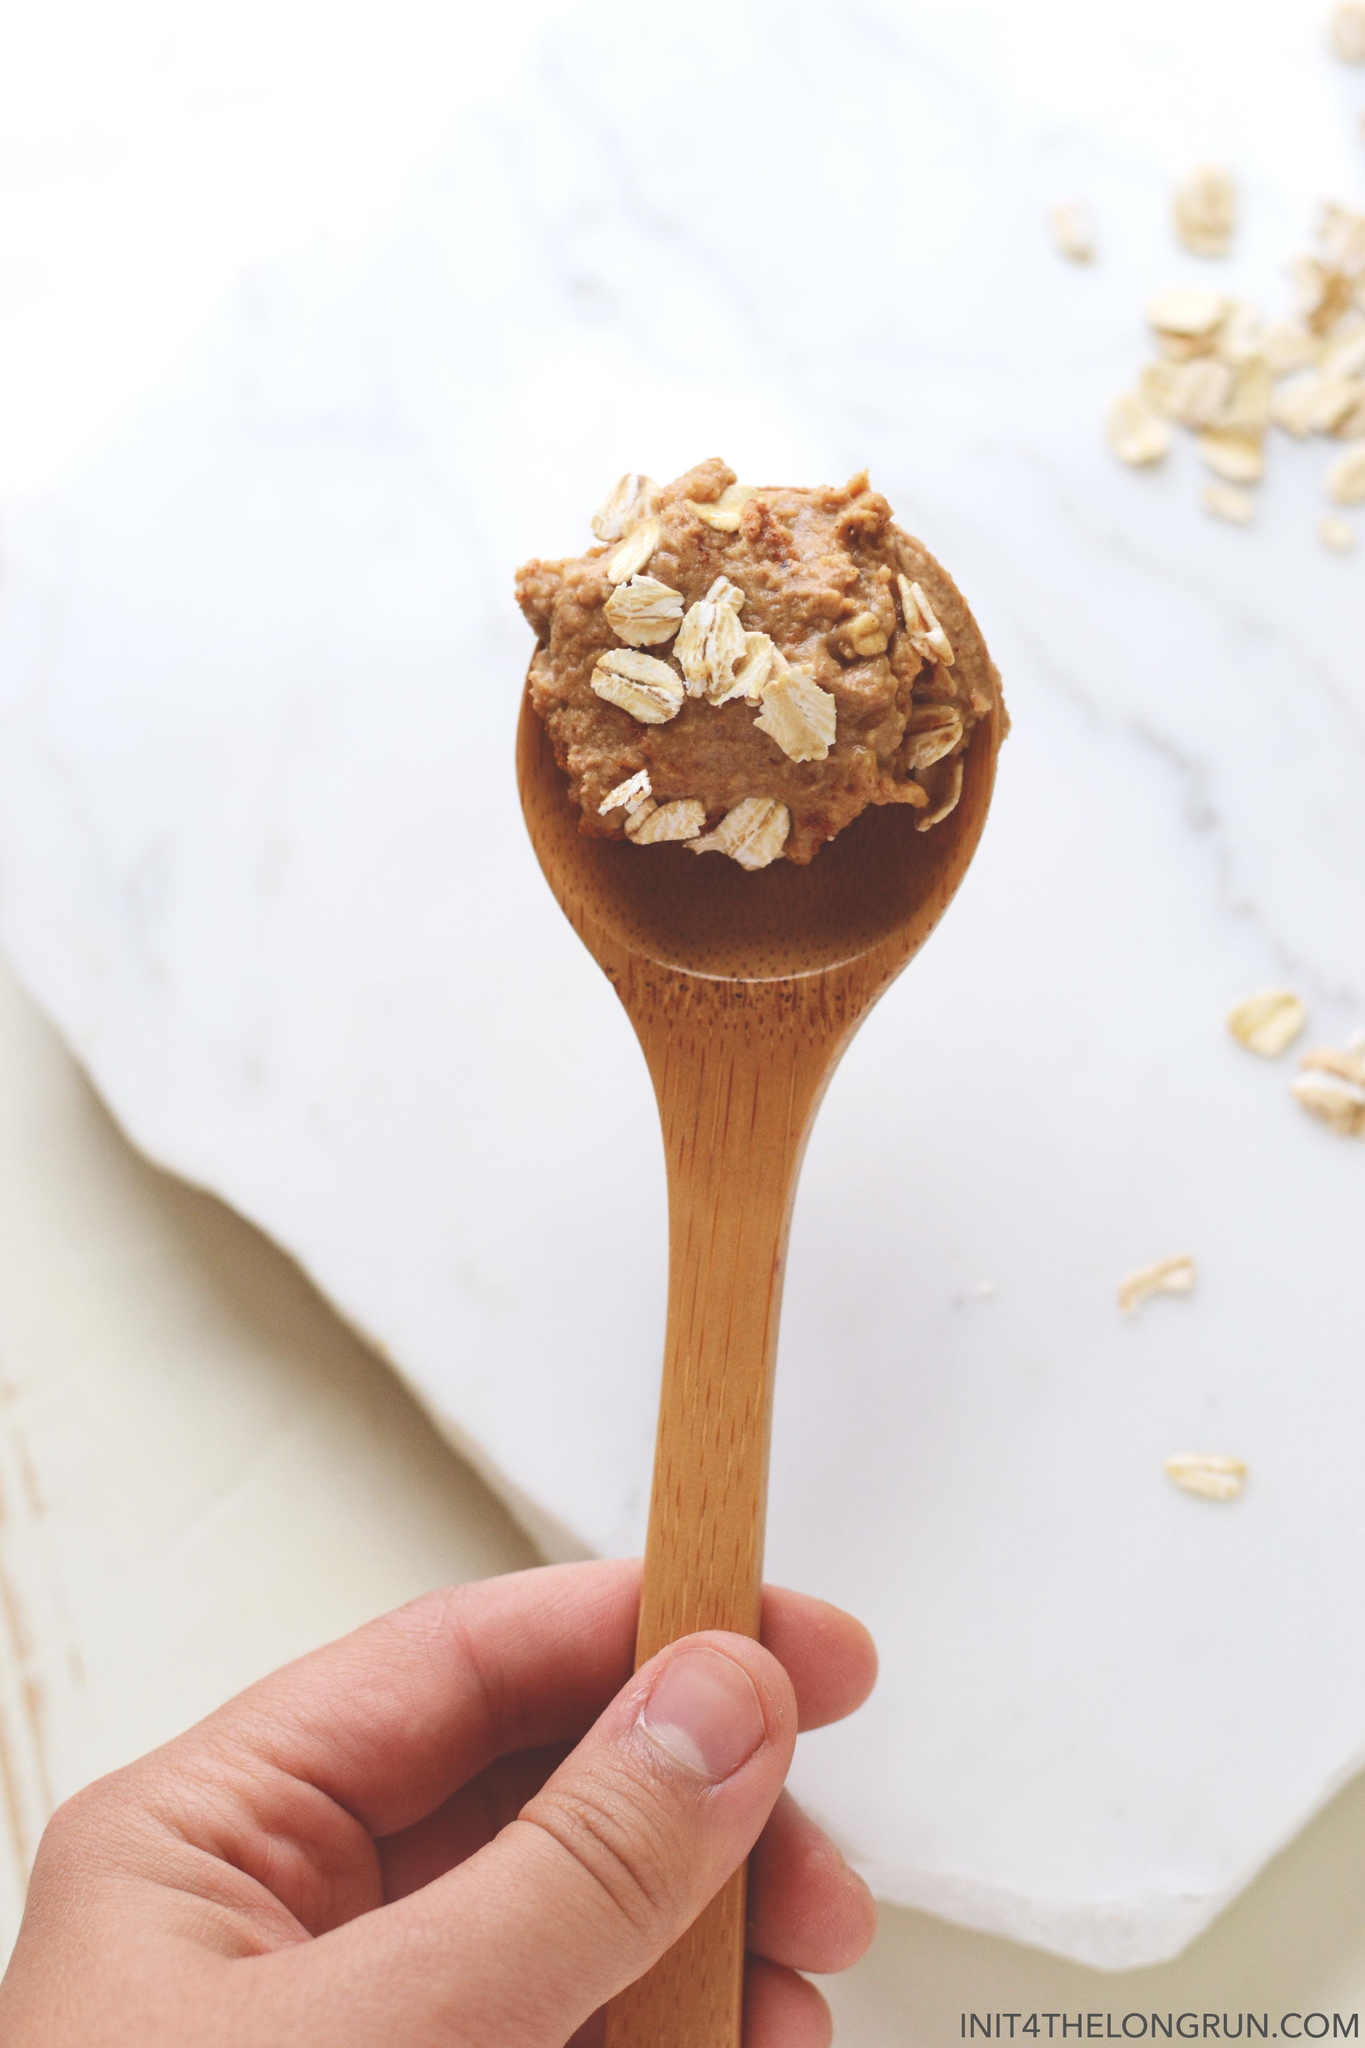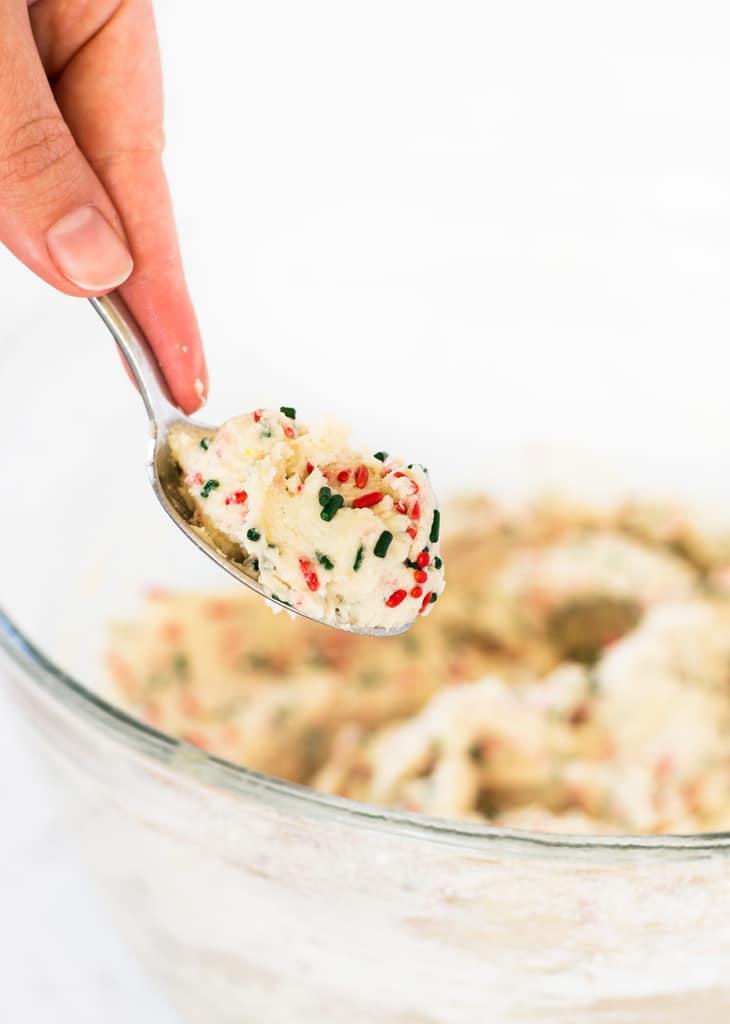The first image is the image on the left, the second image is the image on the right. Considering the images on both sides, is "There is a spoon filled with cookie dough in the center of each image." valid? Answer yes or no. Yes. The first image is the image on the left, the second image is the image on the right. For the images displayed, is the sentence "There is at least one human hand holding a spoon." factually correct? Answer yes or no. Yes. 